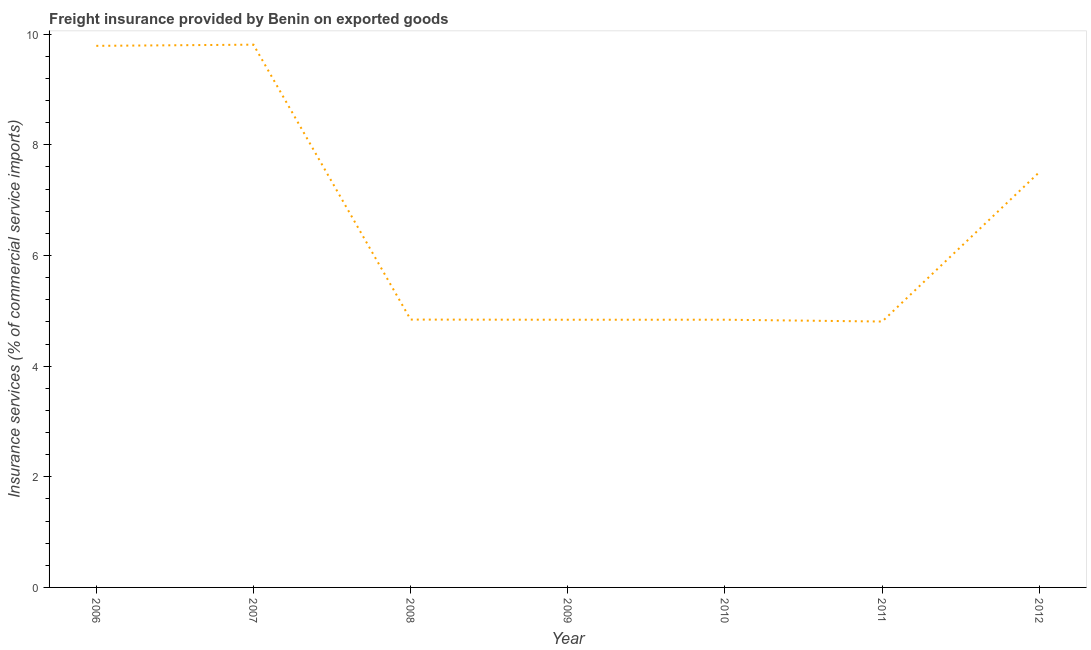What is the freight insurance in 2008?
Give a very brief answer. 4.84. Across all years, what is the maximum freight insurance?
Make the answer very short. 9.81. Across all years, what is the minimum freight insurance?
Offer a terse response. 4.81. In which year was the freight insurance maximum?
Ensure brevity in your answer.  2007. In which year was the freight insurance minimum?
Your answer should be compact. 2011. What is the sum of the freight insurance?
Keep it short and to the point. 46.43. What is the difference between the freight insurance in 2007 and 2010?
Keep it short and to the point. 4.97. What is the average freight insurance per year?
Offer a terse response. 6.63. What is the median freight insurance?
Provide a succinct answer. 4.84. In how many years, is the freight insurance greater than 5.6 %?
Your answer should be compact. 3. Do a majority of the years between 2010 and 2009 (inclusive) have freight insurance greater than 6.8 %?
Provide a succinct answer. No. What is the ratio of the freight insurance in 2007 to that in 2011?
Provide a short and direct response. 2.04. Is the difference between the freight insurance in 2008 and 2012 greater than the difference between any two years?
Your response must be concise. No. What is the difference between the highest and the second highest freight insurance?
Make the answer very short. 0.02. What is the difference between the highest and the lowest freight insurance?
Offer a terse response. 5. Does the freight insurance monotonically increase over the years?
Keep it short and to the point. No. How many lines are there?
Give a very brief answer. 1. How many years are there in the graph?
Give a very brief answer. 7. What is the title of the graph?
Provide a short and direct response. Freight insurance provided by Benin on exported goods . What is the label or title of the Y-axis?
Give a very brief answer. Insurance services (% of commercial service imports). What is the Insurance services (% of commercial service imports) of 2006?
Your answer should be compact. 9.79. What is the Insurance services (% of commercial service imports) of 2007?
Keep it short and to the point. 9.81. What is the Insurance services (% of commercial service imports) of 2008?
Offer a terse response. 4.84. What is the Insurance services (% of commercial service imports) in 2009?
Offer a very short reply. 4.84. What is the Insurance services (% of commercial service imports) in 2010?
Your answer should be very brief. 4.84. What is the Insurance services (% of commercial service imports) in 2011?
Offer a terse response. 4.81. What is the Insurance services (% of commercial service imports) in 2012?
Provide a short and direct response. 7.51. What is the difference between the Insurance services (% of commercial service imports) in 2006 and 2007?
Give a very brief answer. -0.02. What is the difference between the Insurance services (% of commercial service imports) in 2006 and 2008?
Your answer should be compact. 4.95. What is the difference between the Insurance services (% of commercial service imports) in 2006 and 2009?
Your answer should be compact. 4.95. What is the difference between the Insurance services (% of commercial service imports) in 2006 and 2010?
Keep it short and to the point. 4.95. What is the difference between the Insurance services (% of commercial service imports) in 2006 and 2011?
Offer a very short reply. 4.98. What is the difference between the Insurance services (% of commercial service imports) in 2006 and 2012?
Make the answer very short. 2.28. What is the difference between the Insurance services (% of commercial service imports) in 2007 and 2008?
Give a very brief answer. 4.97. What is the difference between the Insurance services (% of commercial service imports) in 2007 and 2009?
Your answer should be very brief. 4.97. What is the difference between the Insurance services (% of commercial service imports) in 2007 and 2010?
Provide a succinct answer. 4.97. What is the difference between the Insurance services (% of commercial service imports) in 2007 and 2011?
Keep it short and to the point. 5. What is the difference between the Insurance services (% of commercial service imports) in 2007 and 2012?
Provide a succinct answer. 2.3. What is the difference between the Insurance services (% of commercial service imports) in 2008 and 2009?
Give a very brief answer. 0. What is the difference between the Insurance services (% of commercial service imports) in 2008 and 2010?
Give a very brief answer. 0. What is the difference between the Insurance services (% of commercial service imports) in 2008 and 2011?
Offer a terse response. 0.04. What is the difference between the Insurance services (% of commercial service imports) in 2008 and 2012?
Offer a very short reply. -2.67. What is the difference between the Insurance services (% of commercial service imports) in 2009 and 2010?
Provide a short and direct response. -0. What is the difference between the Insurance services (% of commercial service imports) in 2009 and 2011?
Your response must be concise. 0.03. What is the difference between the Insurance services (% of commercial service imports) in 2009 and 2012?
Offer a very short reply. -2.67. What is the difference between the Insurance services (% of commercial service imports) in 2010 and 2011?
Provide a short and direct response. 0.03. What is the difference between the Insurance services (% of commercial service imports) in 2010 and 2012?
Provide a succinct answer. -2.67. What is the difference between the Insurance services (% of commercial service imports) in 2011 and 2012?
Offer a very short reply. -2.7. What is the ratio of the Insurance services (% of commercial service imports) in 2006 to that in 2008?
Your answer should be very brief. 2.02. What is the ratio of the Insurance services (% of commercial service imports) in 2006 to that in 2009?
Offer a terse response. 2.02. What is the ratio of the Insurance services (% of commercial service imports) in 2006 to that in 2010?
Ensure brevity in your answer.  2.02. What is the ratio of the Insurance services (% of commercial service imports) in 2006 to that in 2011?
Your answer should be compact. 2.04. What is the ratio of the Insurance services (% of commercial service imports) in 2006 to that in 2012?
Provide a short and direct response. 1.3. What is the ratio of the Insurance services (% of commercial service imports) in 2007 to that in 2008?
Your response must be concise. 2.03. What is the ratio of the Insurance services (% of commercial service imports) in 2007 to that in 2009?
Your answer should be compact. 2.03. What is the ratio of the Insurance services (% of commercial service imports) in 2007 to that in 2010?
Keep it short and to the point. 2.03. What is the ratio of the Insurance services (% of commercial service imports) in 2007 to that in 2011?
Ensure brevity in your answer.  2.04. What is the ratio of the Insurance services (% of commercial service imports) in 2007 to that in 2012?
Give a very brief answer. 1.31. What is the ratio of the Insurance services (% of commercial service imports) in 2008 to that in 2012?
Provide a short and direct response. 0.65. What is the ratio of the Insurance services (% of commercial service imports) in 2009 to that in 2012?
Your response must be concise. 0.65. What is the ratio of the Insurance services (% of commercial service imports) in 2010 to that in 2012?
Your response must be concise. 0.65. What is the ratio of the Insurance services (% of commercial service imports) in 2011 to that in 2012?
Your answer should be very brief. 0.64. 